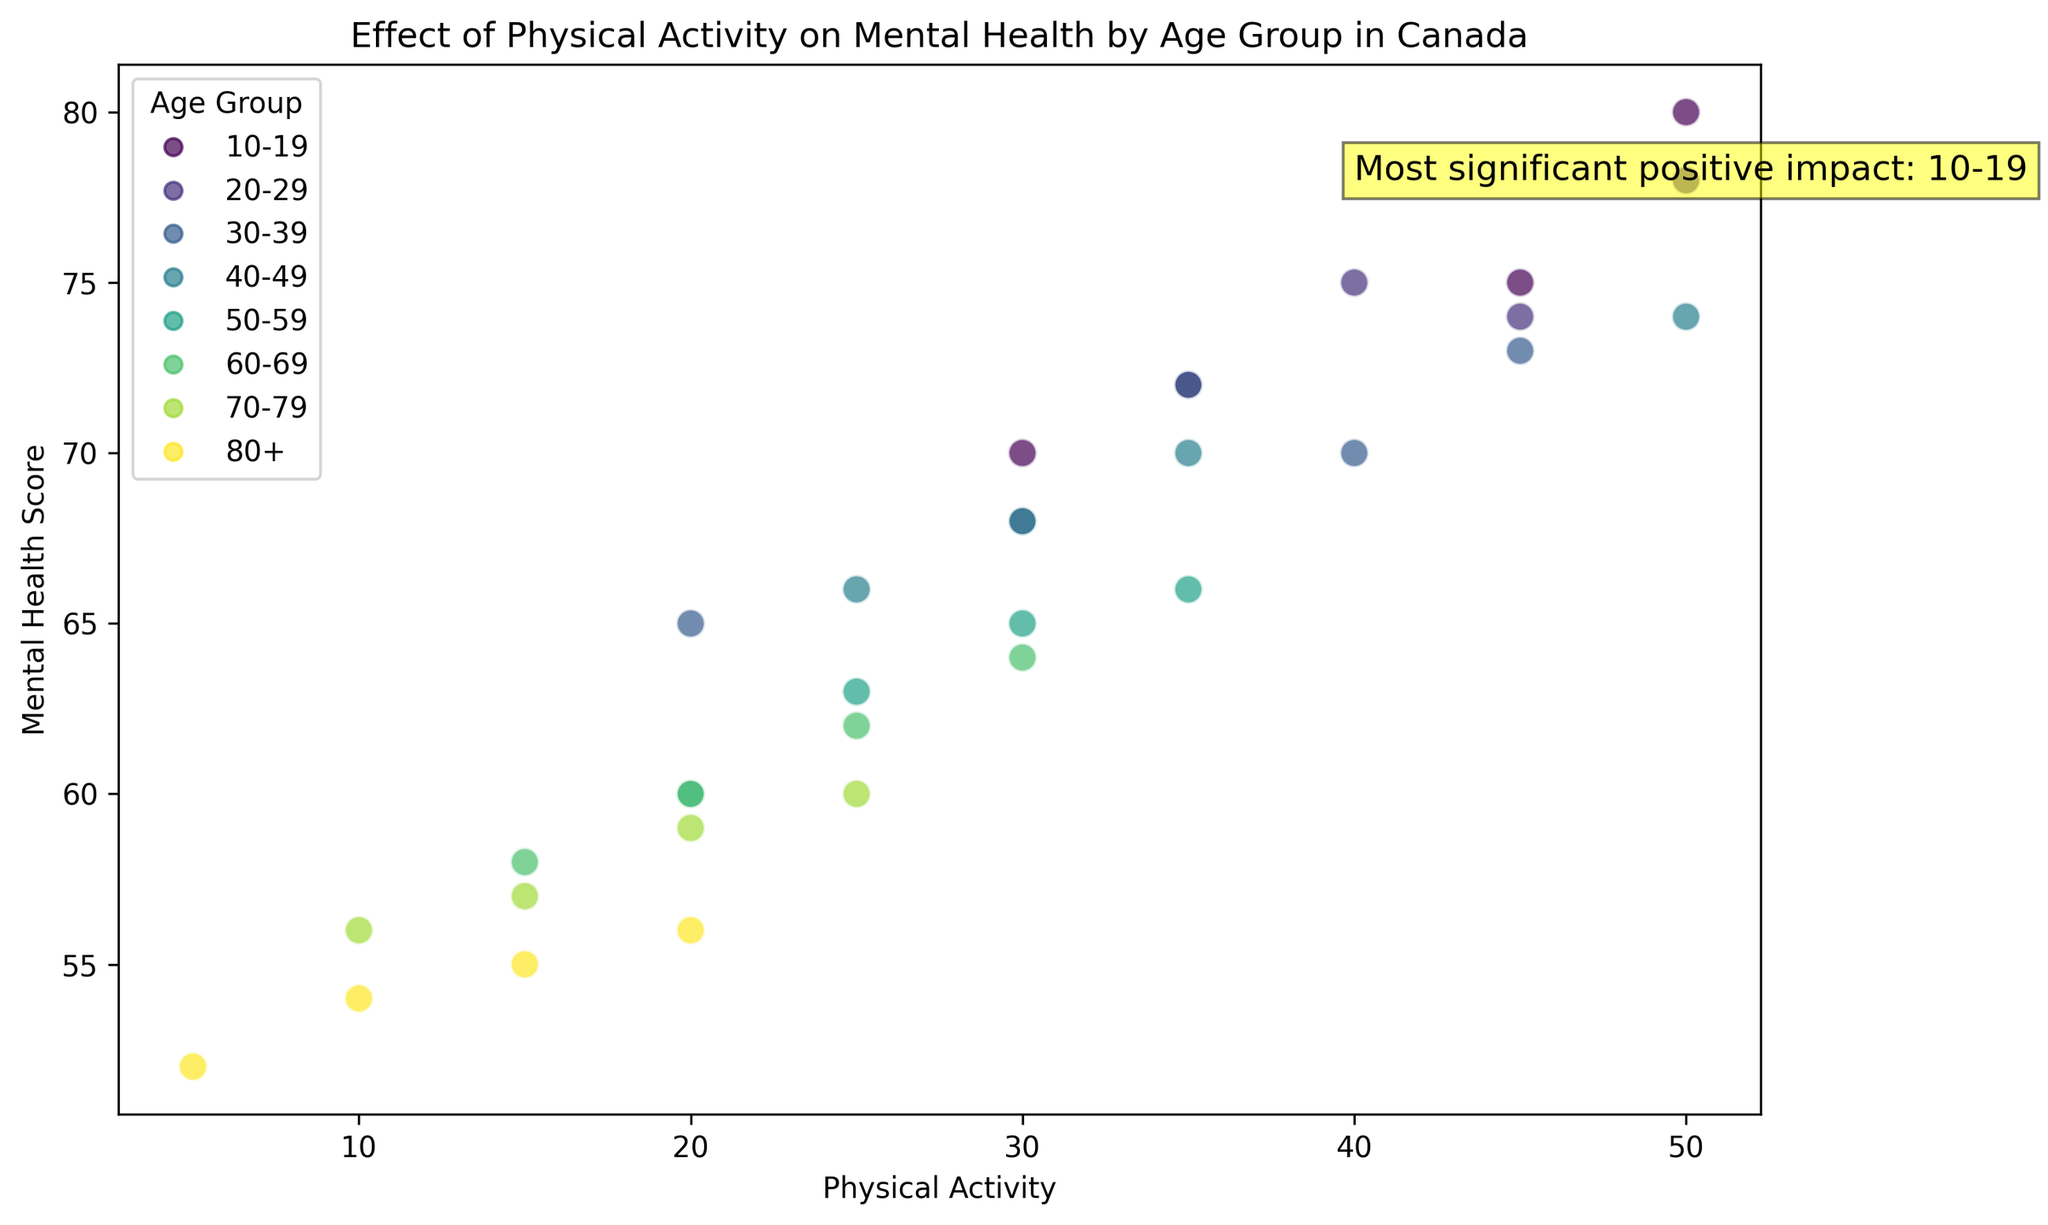What is the age group labeled as having the most significant positive impact? The annotation on the scatter plot specifically mentions that the age group with the most significant positive impact is "10-19". This can be seen in the text written on the plot.
Answer: 10-19 Which age group generally has the highest mental health scores? By observing the scatter plot, data points for the 10-19 age group are generally positioned higher on the y-axis (mental health score) compared to other age groups indicating they generally have the highest scores.
Answer: 10-19 What is the average mental health score for the age group 20-29? Add the mental health scores for the 20-29 age group (68 + 78 + 75 + 74 = 295) and divide by the number of data points (4). The average is 295 / 4 = 73.75.
Answer: 73.75 Which age group has the highest range in physical activity levels? By comparing the spread of the data points along the x-axis among different age groups, the 20-29 age group shows the highest range in physical activity levels (from 30 to 50, range = 20 units).
Answer: 20-29 How does the mental health score change with increased physical activity for the age group 50-59? For age group 50-59, the mental health scores appear to increase as the physical activity levels increase. This is evident from the upward trend of the data points within that age group.
Answer: Increases Which age group has the lowest mental health scores? The 80+ age group has the lowest mental health scores, with the data points positioned lowest on the y-axis compared to other age groups.
Answer: 80+ Is there a strong correlation between physical activity and mental health score for the age group 30-39? By examining the scatter plot, you can see that the data points for the 30-39 age group are relatively clustered without a clear, strong upward or downward trend, suggesting a weaker correlation.
Answer: No What is the average physical activity level for the 60-69 age group? Add the physical activity levels for the 60-69 age group (15 + 20 + 25 + 30 = 90) and divide by the number of data points (4). The average is 90 / 4 = 22.5.
Answer: 22.5 Compare the mental health scores for participants with 45 units of physical activity across different age groups. Looking at the data points for participants with 45 units of physical activity, the mental health scores are: 75 (10-19), 74 (20-29), 73 (30-39). The highest score is for the age group 10-19.
Answer: 10-19 